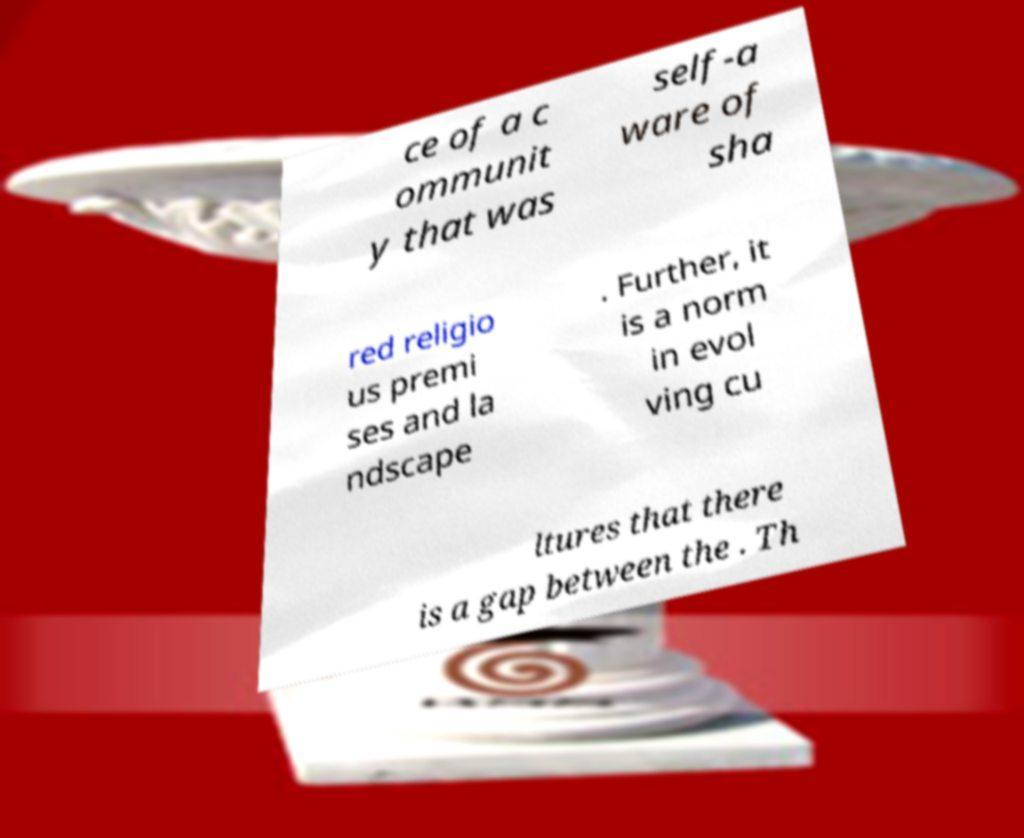Please read and relay the text visible in this image. What does it say? ce of a c ommunit y that was self-a ware of sha red religio us premi ses and la ndscape . Further, it is a norm in evol ving cu ltures that there is a gap between the . Th 